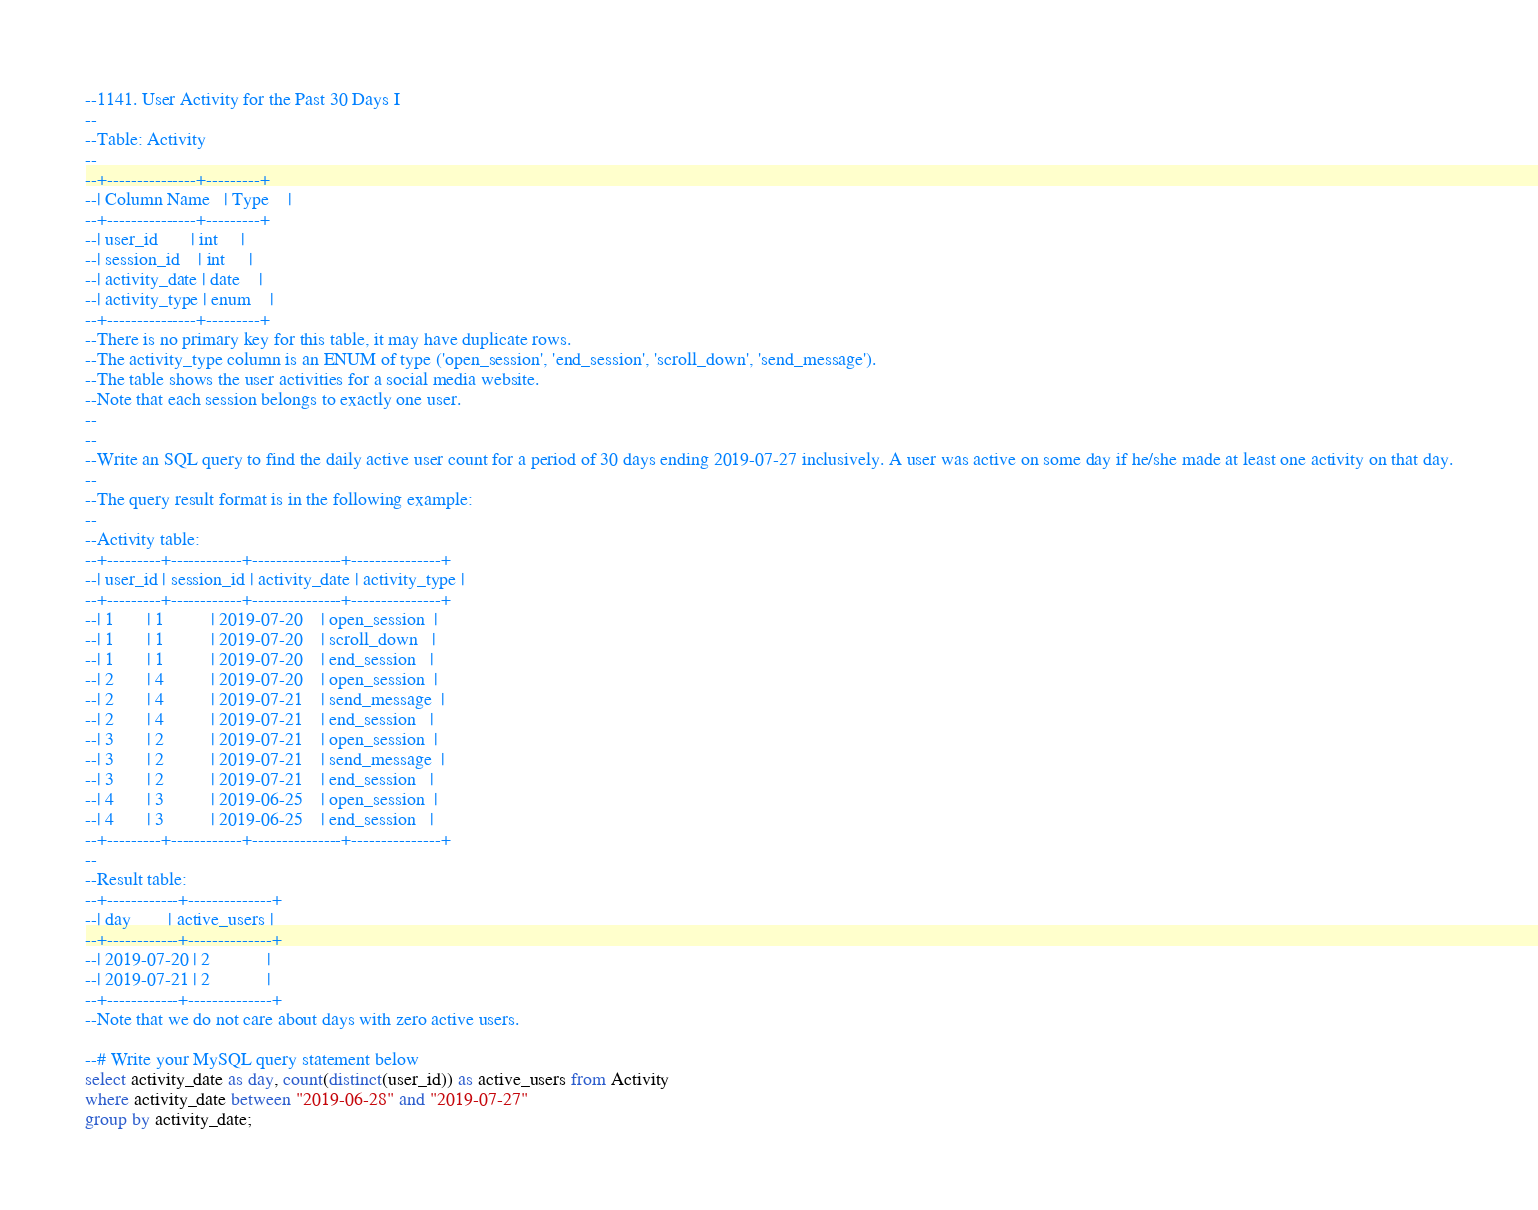Convert code to text. <code><loc_0><loc_0><loc_500><loc_500><_SQL_>--1141. User Activity for the Past 30 Days I
--
--Table: Activity
--
--+---------------+---------+
--| Column Name   | Type    |
--+---------------+---------+
--| user_id       | int     |
--| session_id    | int     |
--| activity_date | date    |
--| activity_type | enum    |
--+---------------+---------+
--There is no primary key for this table, it may have duplicate rows.
--The activity_type column is an ENUM of type ('open_session', 'end_session', 'scroll_down', 'send_message').
--The table shows the user activities for a social media website.
--Note that each session belongs to exactly one user.
--
--
--Write an SQL query to find the daily active user count for a period of 30 days ending 2019-07-27 inclusively. A user was active on some day if he/she made at least one activity on that day.
--
--The query result format is in the following example:
--
--Activity table:
--+---------+------------+---------------+---------------+
--| user_id | session_id | activity_date | activity_type |
--+---------+------------+---------------+---------------+
--| 1       | 1          | 2019-07-20    | open_session  |
--| 1       | 1          | 2019-07-20    | scroll_down   |
--| 1       | 1          | 2019-07-20    | end_session   |
--| 2       | 4          | 2019-07-20    | open_session  |
--| 2       | 4          | 2019-07-21    | send_message  |
--| 2       | 4          | 2019-07-21    | end_session   |
--| 3       | 2          | 2019-07-21    | open_session  |
--| 3       | 2          | 2019-07-21    | send_message  |
--| 3       | 2          | 2019-07-21    | end_session   |
--| 4       | 3          | 2019-06-25    | open_session  |
--| 4       | 3          | 2019-06-25    | end_session   |
--+---------+------------+---------------+---------------+
--
--Result table:
--+------------+--------------+
--| day        | active_users |
--+------------+--------------+
--| 2019-07-20 | 2            |
--| 2019-07-21 | 2            |
--+------------+--------------+
--Note that we do not care about days with zero active users.

--# Write your MySQL query statement below
select activity_date as day, count(distinct(user_id)) as active_users from Activity
where activity_date between "2019-06-28" and "2019-07-27"
group by activity_date;</code> 